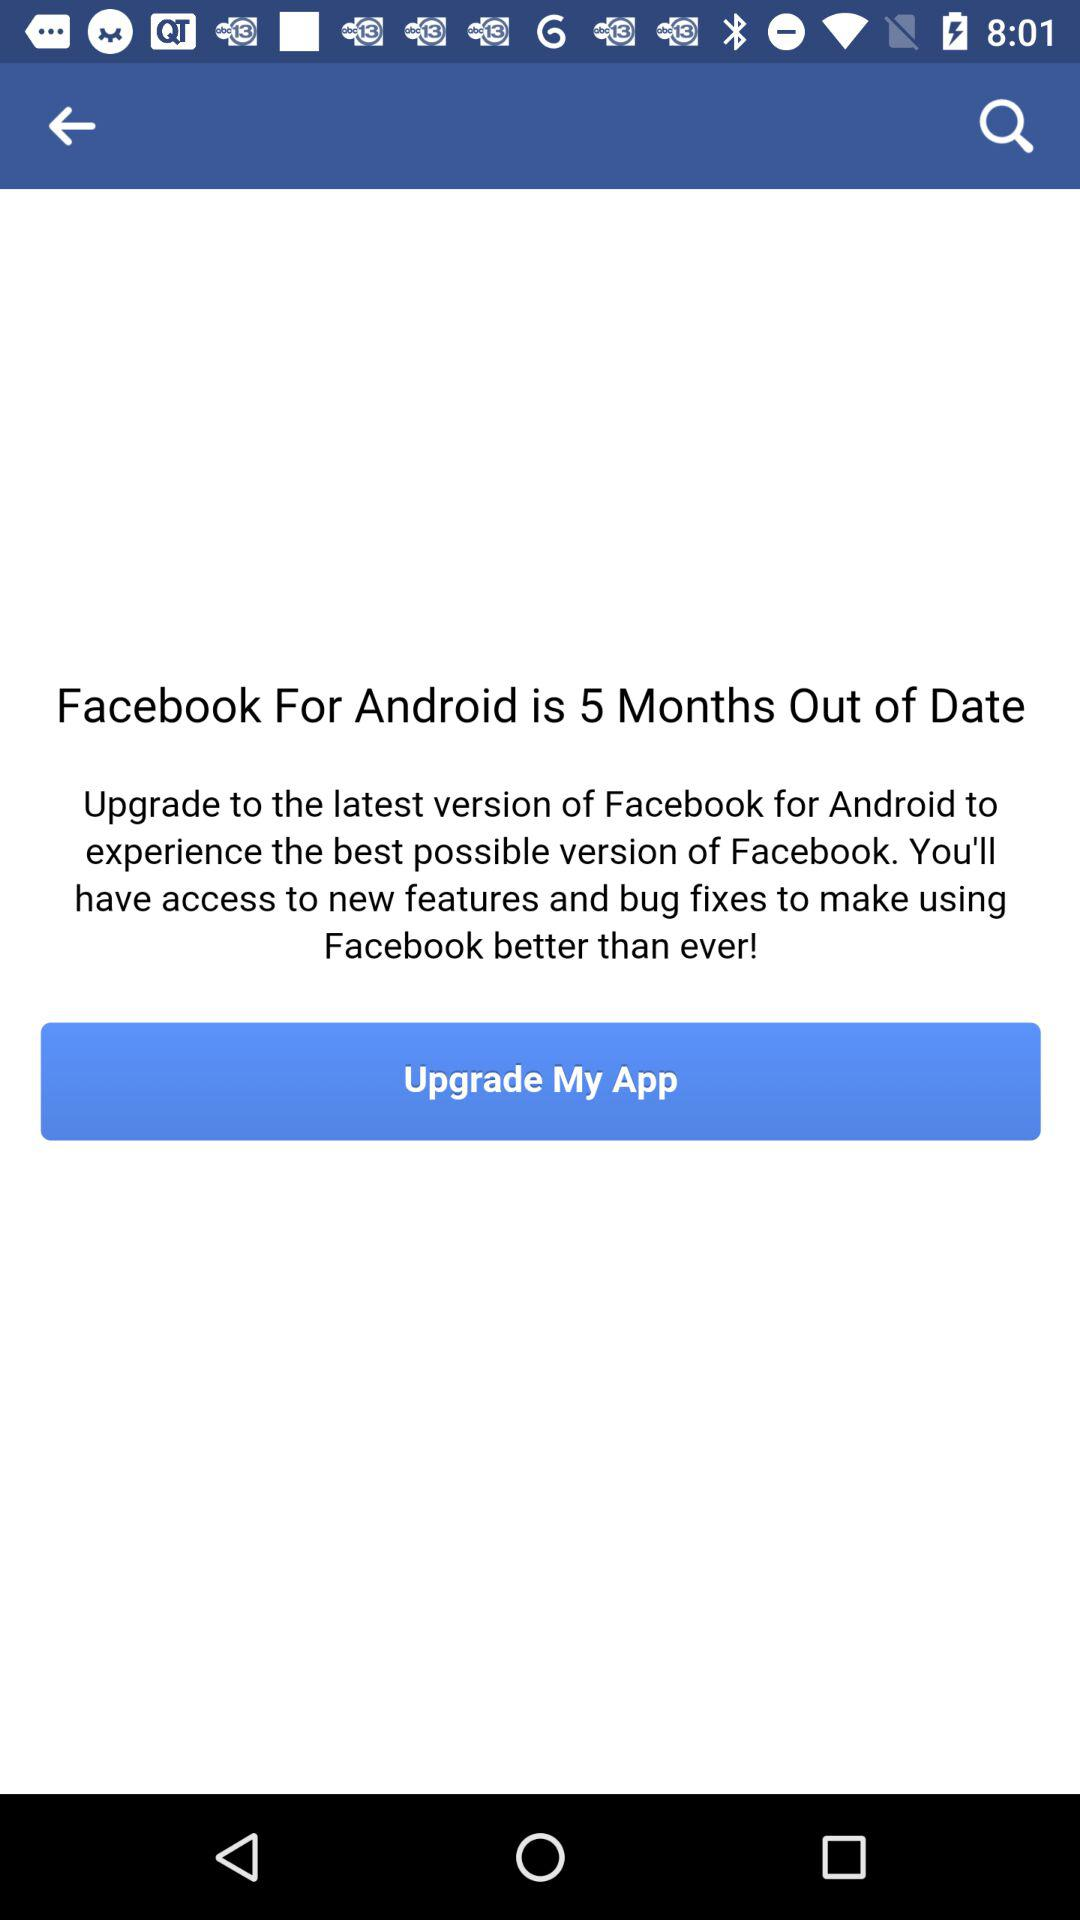How many months older is the current version of Facebook for Android than the version on this device?
Answer the question using a single word or phrase. 5 